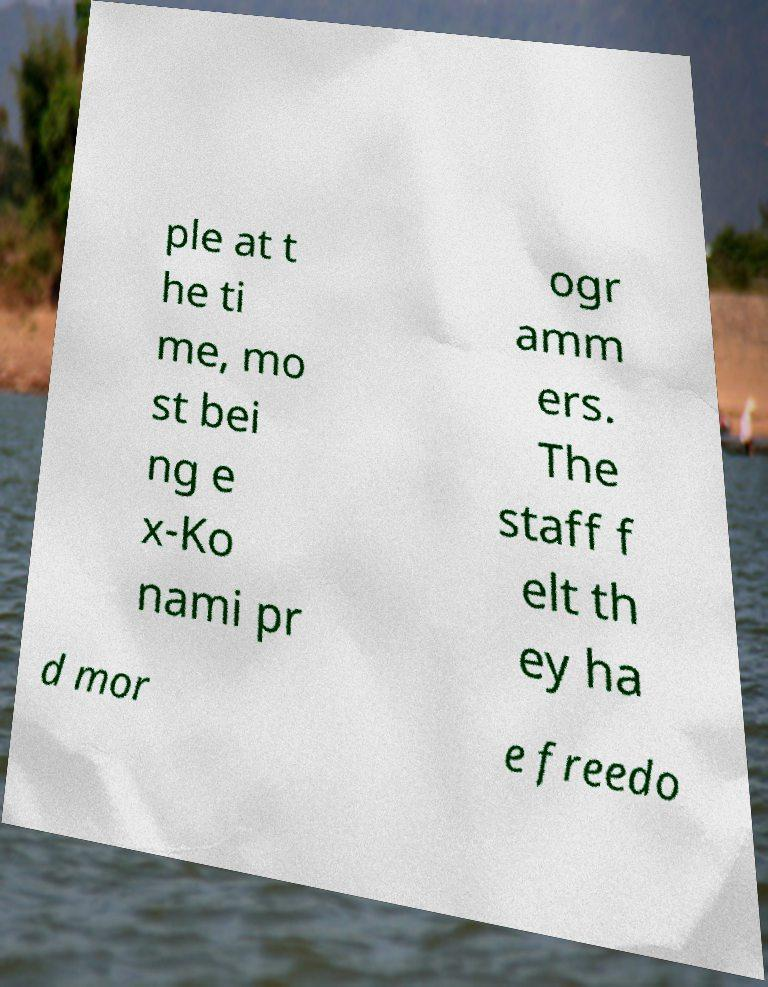Could you extract and type out the text from this image? ple at t he ti me, mo st bei ng e x-Ko nami pr ogr amm ers. The staff f elt th ey ha d mor e freedo 